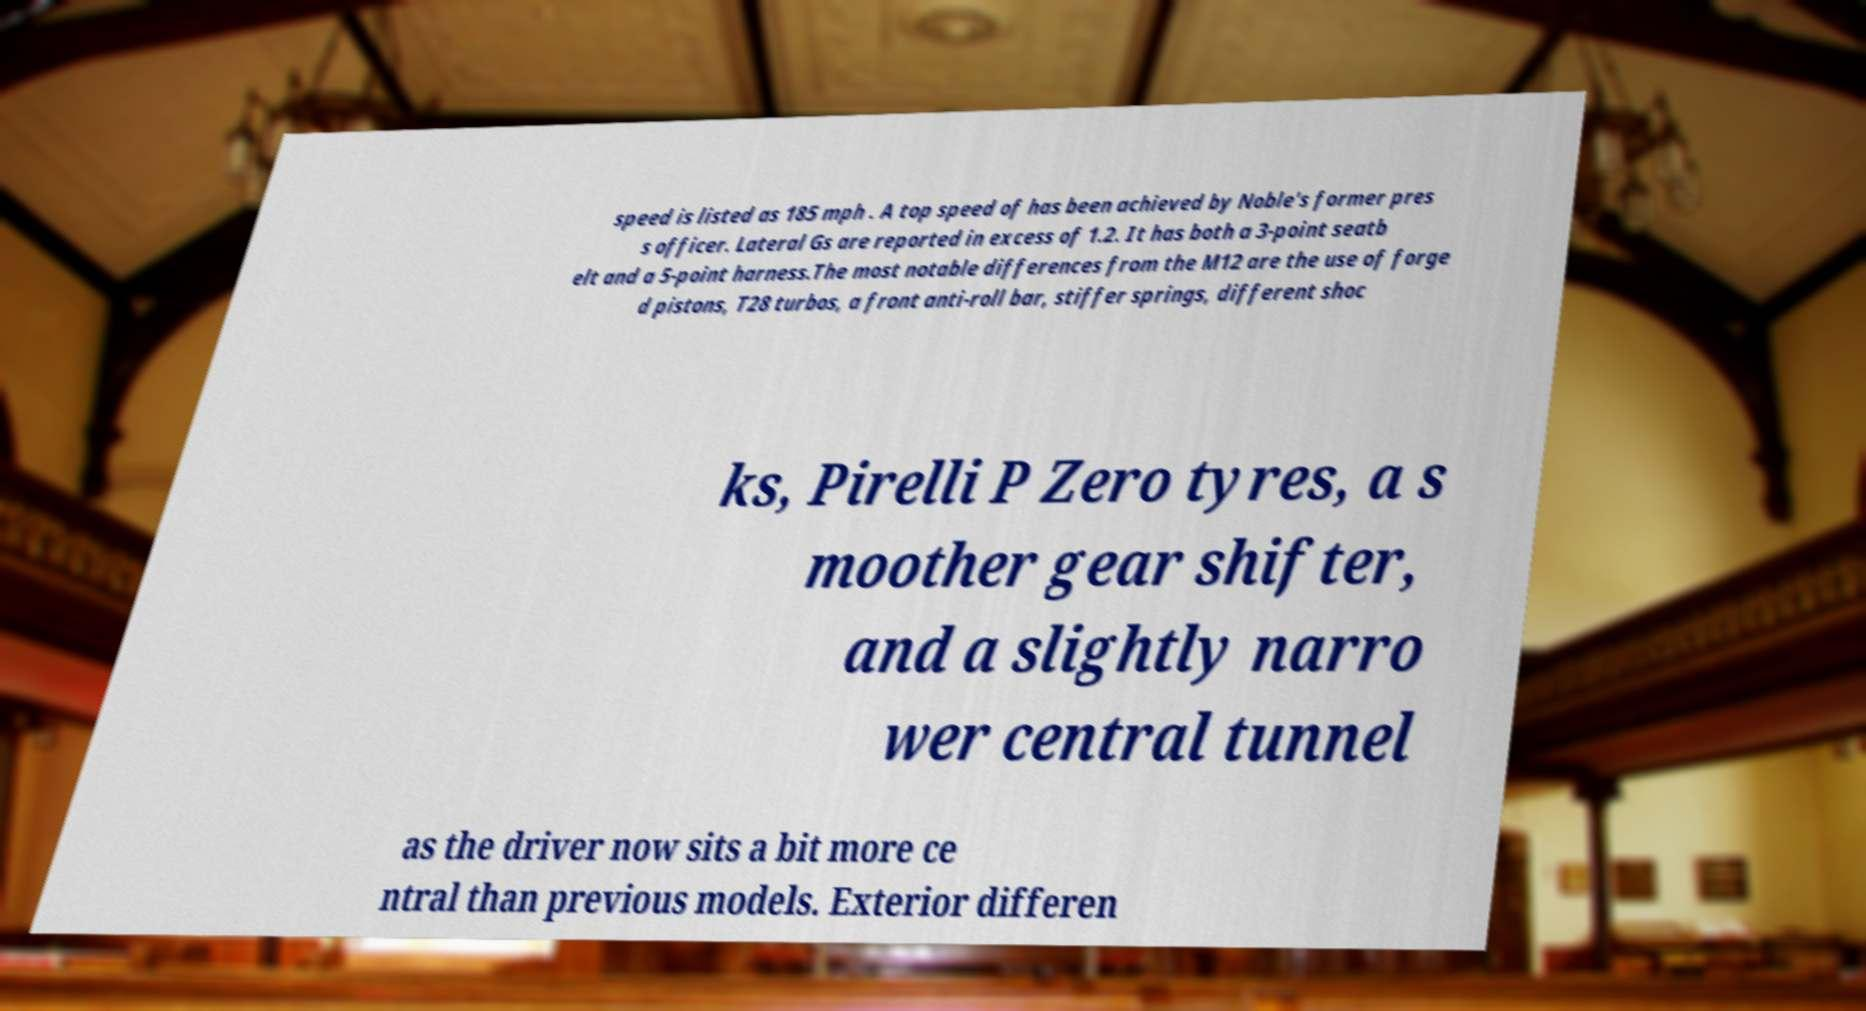Please identify and transcribe the text found in this image. speed is listed as 185 mph . A top speed of has been achieved by Noble's former pres s officer. Lateral Gs are reported in excess of 1.2. It has both a 3-point seatb elt and a 5-point harness.The most notable differences from the M12 are the use of forge d pistons, T28 turbos, a front anti-roll bar, stiffer springs, different shoc ks, Pirelli P Zero tyres, a s moother gear shifter, and a slightly narro wer central tunnel as the driver now sits a bit more ce ntral than previous models. Exterior differen 